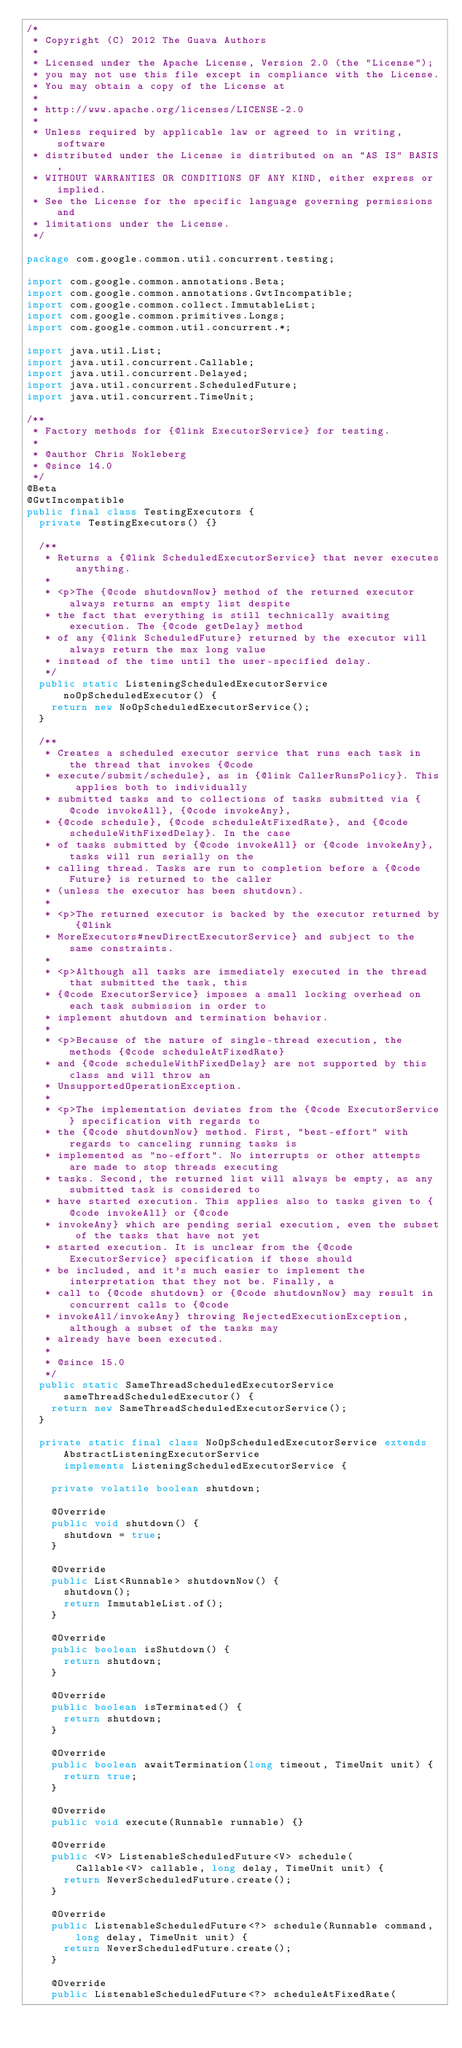<code> <loc_0><loc_0><loc_500><loc_500><_Java_>/*
 * Copyright (C) 2012 The Guava Authors
 *
 * Licensed under the Apache License, Version 2.0 (the "License");
 * you may not use this file except in compliance with the License.
 * You may obtain a copy of the License at
 *
 * http://www.apache.org/licenses/LICENSE-2.0
 *
 * Unless required by applicable law or agreed to in writing, software
 * distributed under the License is distributed on an "AS IS" BASIS,
 * WITHOUT WARRANTIES OR CONDITIONS OF ANY KIND, either express or implied.
 * See the License for the specific language governing permissions and
 * limitations under the License.
 */

package com.google.common.util.concurrent.testing;

import com.google.common.annotations.Beta;
import com.google.common.annotations.GwtIncompatible;
import com.google.common.collect.ImmutableList;
import com.google.common.primitives.Longs;
import com.google.common.util.concurrent.*;

import java.util.List;
import java.util.concurrent.Callable;
import java.util.concurrent.Delayed;
import java.util.concurrent.ScheduledFuture;
import java.util.concurrent.TimeUnit;

/**
 * Factory methods for {@link ExecutorService} for testing.
 *
 * @author Chris Nokleberg
 * @since 14.0
 */
@Beta
@GwtIncompatible
public final class TestingExecutors {
  private TestingExecutors() {}

  /**
   * Returns a {@link ScheduledExecutorService} that never executes anything.
   *
   * <p>The {@code shutdownNow} method of the returned executor always returns an empty list despite
   * the fact that everything is still technically awaiting execution. The {@code getDelay} method
   * of any {@link ScheduledFuture} returned by the executor will always return the max long value
   * instead of the time until the user-specified delay.
   */
  public static ListeningScheduledExecutorService noOpScheduledExecutor() {
    return new NoOpScheduledExecutorService();
  }

  /**
   * Creates a scheduled executor service that runs each task in the thread that invokes {@code
   * execute/submit/schedule}, as in {@link CallerRunsPolicy}. This applies both to individually
   * submitted tasks and to collections of tasks submitted via {@code invokeAll}, {@code invokeAny},
   * {@code schedule}, {@code scheduleAtFixedRate}, and {@code scheduleWithFixedDelay}. In the case
   * of tasks submitted by {@code invokeAll} or {@code invokeAny}, tasks will run serially on the
   * calling thread. Tasks are run to completion before a {@code Future} is returned to the caller
   * (unless the executor has been shutdown).
   *
   * <p>The returned executor is backed by the executor returned by {@link
   * MoreExecutors#newDirectExecutorService} and subject to the same constraints.
   *
   * <p>Although all tasks are immediately executed in the thread that submitted the task, this
   * {@code ExecutorService} imposes a small locking overhead on each task submission in order to
   * implement shutdown and termination behavior.
   *
   * <p>Because of the nature of single-thread execution, the methods {@code scheduleAtFixedRate}
   * and {@code scheduleWithFixedDelay} are not supported by this class and will throw an
   * UnsupportedOperationException.
   *
   * <p>The implementation deviates from the {@code ExecutorService} specification with regards to
   * the {@code shutdownNow} method. First, "best-effort" with regards to canceling running tasks is
   * implemented as "no-effort". No interrupts or other attempts are made to stop threads executing
   * tasks. Second, the returned list will always be empty, as any submitted task is considered to
   * have started execution. This applies also to tasks given to {@code invokeAll} or {@code
   * invokeAny} which are pending serial execution, even the subset of the tasks that have not yet
   * started execution. It is unclear from the {@code ExecutorService} specification if these should
   * be included, and it's much easier to implement the interpretation that they not be. Finally, a
   * call to {@code shutdown} or {@code shutdownNow} may result in concurrent calls to {@code
   * invokeAll/invokeAny} throwing RejectedExecutionException, although a subset of the tasks may
   * already have been executed.
   *
   * @since 15.0
   */
  public static SameThreadScheduledExecutorService sameThreadScheduledExecutor() {
    return new SameThreadScheduledExecutorService();
  }

  private static final class NoOpScheduledExecutorService extends AbstractListeningExecutorService
      implements ListeningScheduledExecutorService {

    private volatile boolean shutdown;

    @Override
    public void shutdown() {
      shutdown = true;
    }

    @Override
    public List<Runnable> shutdownNow() {
      shutdown();
      return ImmutableList.of();
    }

    @Override
    public boolean isShutdown() {
      return shutdown;
    }

    @Override
    public boolean isTerminated() {
      return shutdown;
    }

    @Override
    public boolean awaitTermination(long timeout, TimeUnit unit) {
      return true;
    }

    @Override
    public void execute(Runnable runnable) {}

    @Override
    public <V> ListenableScheduledFuture<V> schedule(
        Callable<V> callable, long delay, TimeUnit unit) {
      return NeverScheduledFuture.create();
    }

    @Override
    public ListenableScheduledFuture<?> schedule(Runnable command, long delay, TimeUnit unit) {
      return NeverScheduledFuture.create();
    }

    @Override
    public ListenableScheduledFuture<?> scheduleAtFixedRate(</code> 